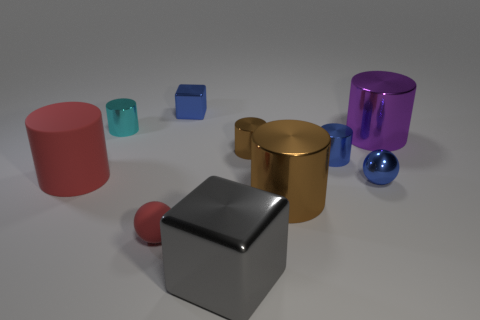What is the color of the big metallic thing behind the rubber thing that is behind the metallic cylinder that is in front of the red cylinder?
Give a very brief answer. Purple. How many rubber cylinders are in front of the brown thing behind the brown metal thing that is in front of the tiny shiny sphere?
Provide a succinct answer. 1. Are there any other things of the same color as the big matte thing?
Provide a short and direct response. Yes. There is a cylinder that is behind the purple object; is it the same size as the gray metal object?
Your answer should be very brief. No. What number of large brown shiny cylinders are on the right side of the rubber ball on the left side of the purple object?
Your response must be concise. 1. There is a block that is in front of the brown cylinder that is in front of the blue sphere; is there a red rubber ball that is on the right side of it?
Offer a terse response. No. What is the material of the red thing that is the same shape as the big brown thing?
Your response must be concise. Rubber. Is there anything else that is made of the same material as the tiny blue block?
Your answer should be compact. Yes. Do the big brown cylinder and the red object that is in front of the large red cylinder have the same material?
Your answer should be very brief. No. What shape is the large matte object on the left side of the big metallic cylinder that is behind the tiny blue metallic ball?
Your answer should be compact. Cylinder. 